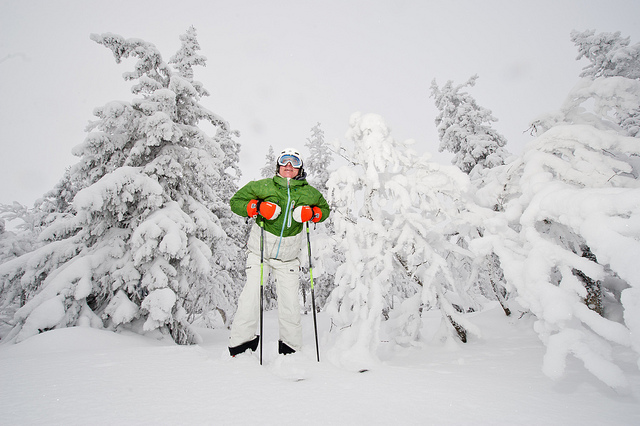<image>What is the green round object in the background? The green round object in the background is ambiguous. It can be a coat, skier or a jacket. What is the green round object in the background? I don't know what the green round object in the background is. It can be a coat, jacket or something else. 